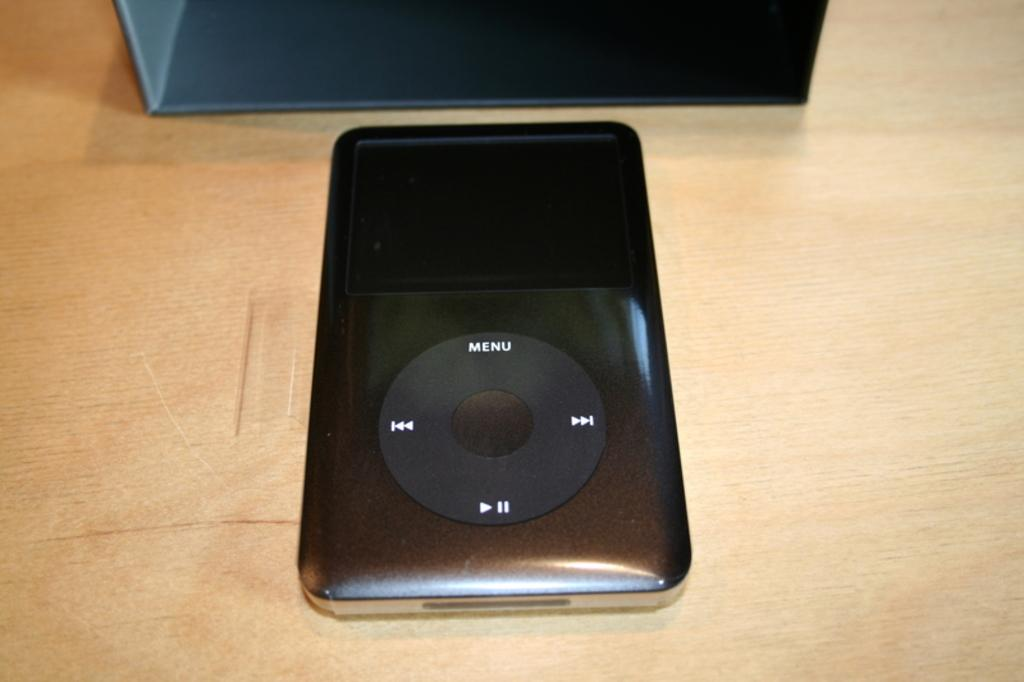What type of electronic device is in the image? There is a small black iPod music player in the image. Where is the iPod placed? The iPod is placed on a wooden table top. What can be seen behind the iPod? There is a black box behind the iPod. What type of rose is growing on the iPod in the image? There is no rose present in the image; it features an iPod music player and a black box. 